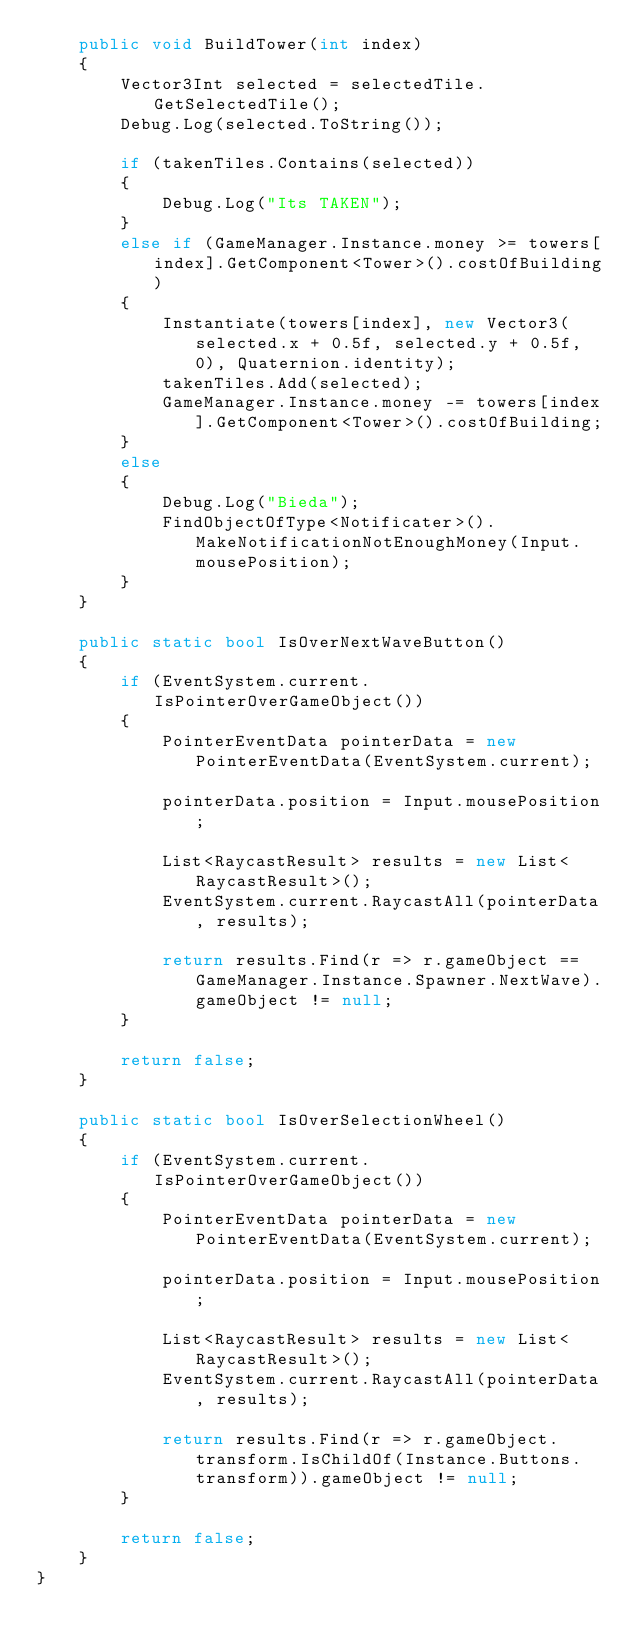<code> <loc_0><loc_0><loc_500><loc_500><_C#_>    public void BuildTower(int index)
    {
        Vector3Int selected = selectedTile.GetSelectedTile();
        Debug.Log(selected.ToString());

        if (takenTiles.Contains(selected))
        {
            Debug.Log("Its TAKEN");
        }
        else if (GameManager.Instance.money >= towers[index].GetComponent<Tower>().costOfBuilding)
        {
            Instantiate(towers[index], new Vector3(selected.x + 0.5f, selected.y + 0.5f, 0), Quaternion.identity);
            takenTiles.Add(selected);
            GameManager.Instance.money -= towers[index].GetComponent<Tower>().costOfBuilding;
        }
        else
        {
            Debug.Log("Bieda");
            FindObjectOfType<Notificater>().MakeNotificationNotEnoughMoney(Input.mousePosition);
        }
    }

    public static bool IsOverNextWaveButton()
    {
        if (EventSystem.current.IsPointerOverGameObject())
        {
            PointerEventData pointerData = new PointerEventData(EventSystem.current);

            pointerData.position = Input.mousePosition;

            List<RaycastResult> results = new List<RaycastResult>();
            EventSystem.current.RaycastAll(pointerData, results);

            return results.Find(r => r.gameObject == GameManager.Instance.Spawner.NextWave).gameObject != null;
        }

        return false;
    }

    public static bool IsOverSelectionWheel()
    {
        if (EventSystem.current.IsPointerOverGameObject())
        {
            PointerEventData pointerData = new PointerEventData(EventSystem.current);

            pointerData.position = Input.mousePosition;

            List<RaycastResult> results = new List<RaycastResult>();
            EventSystem.current.RaycastAll(pointerData, results);

            return results.Find(r => r.gameObject.transform.IsChildOf(Instance.Buttons.transform)).gameObject != null;
        }

        return false;
    }
}
</code> 